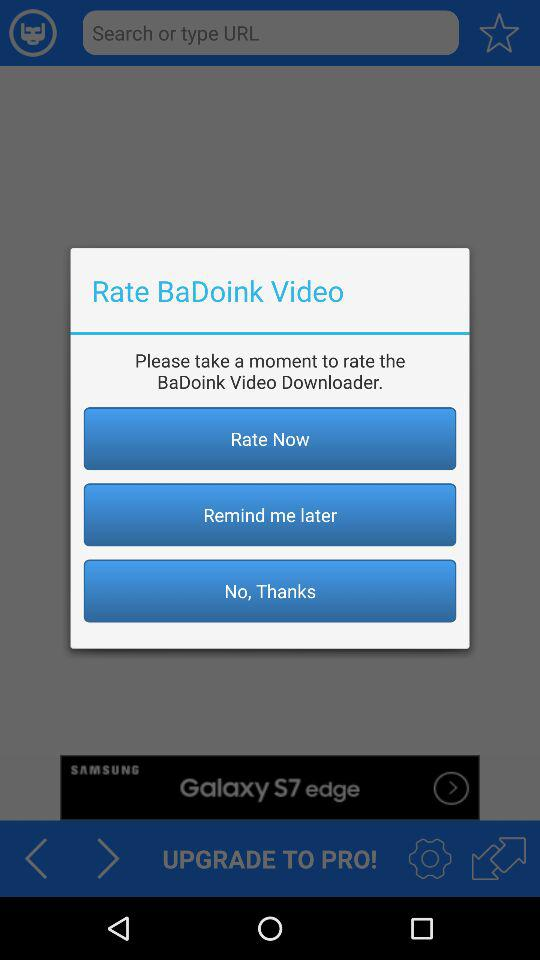What is the name of the application that is to be rated? The name of the application is "BaDoink Video Downloader". 